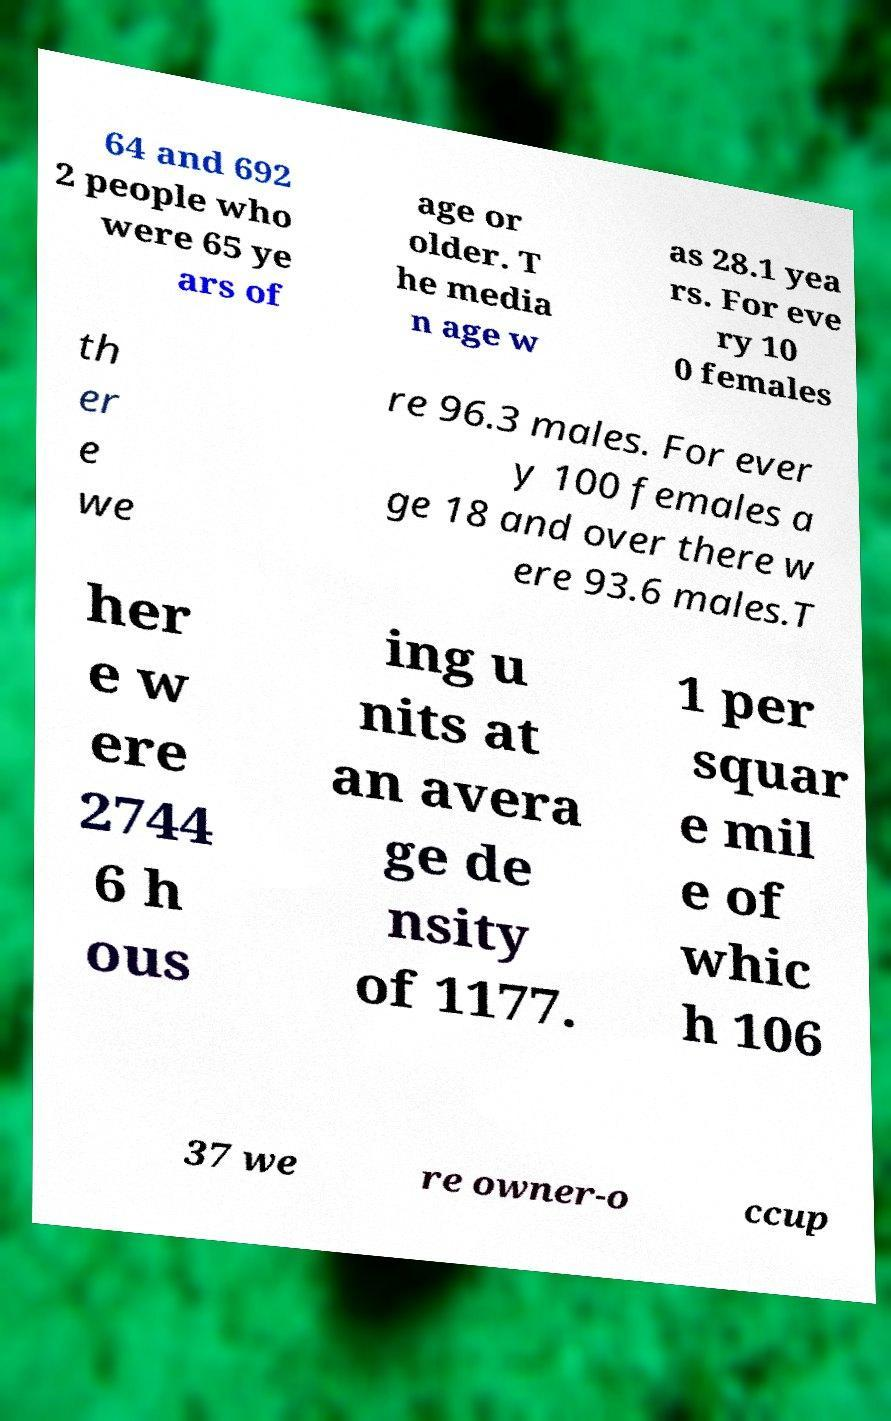Please read and relay the text visible in this image. What does it say? 64 and 692 2 people who were 65 ye ars of age or older. T he media n age w as 28.1 yea rs. For eve ry 10 0 females th er e we re 96.3 males. For ever y 100 females a ge 18 and over there w ere 93.6 males.T her e w ere 2744 6 h ous ing u nits at an avera ge de nsity of 1177. 1 per squar e mil e of whic h 106 37 we re owner-o ccup 